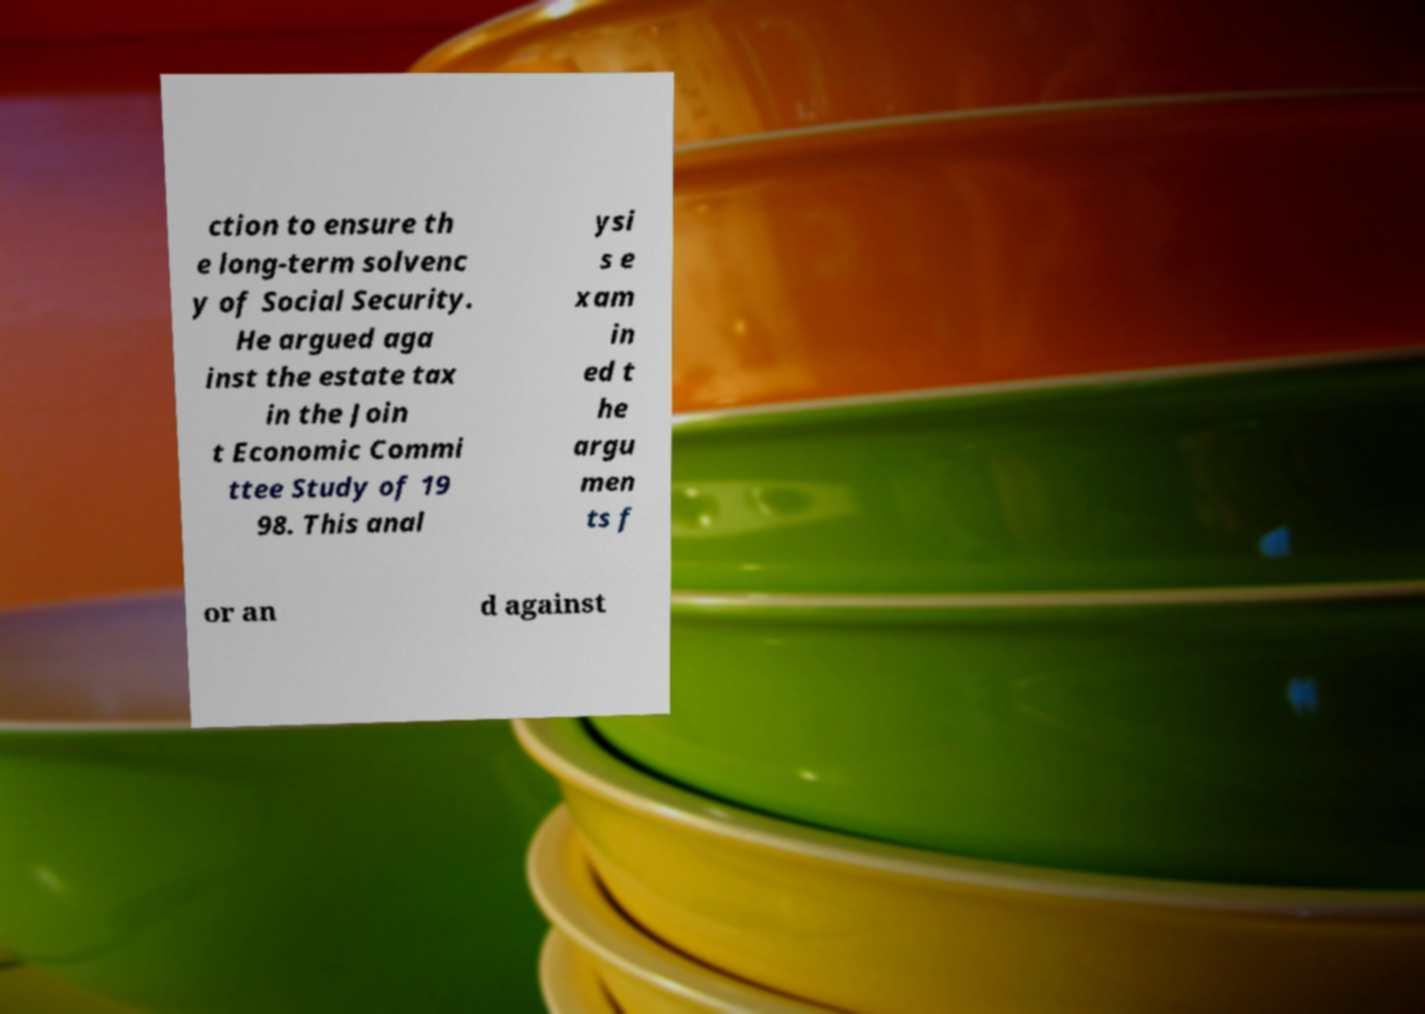Please read and relay the text visible in this image. What does it say? ction to ensure th e long-term solvenc y of Social Security. He argued aga inst the estate tax in the Join t Economic Commi ttee Study of 19 98. This anal ysi s e xam in ed t he argu men ts f or an d against 